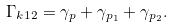Convert formula to latex. <formula><loc_0><loc_0><loc_500><loc_500>\Gamma _ { k 1 2 } = \gamma _ { p } + \gamma _ { { p } _ { 1 } } + \gamma _ { { p } _ { 2 } } .</formula> 